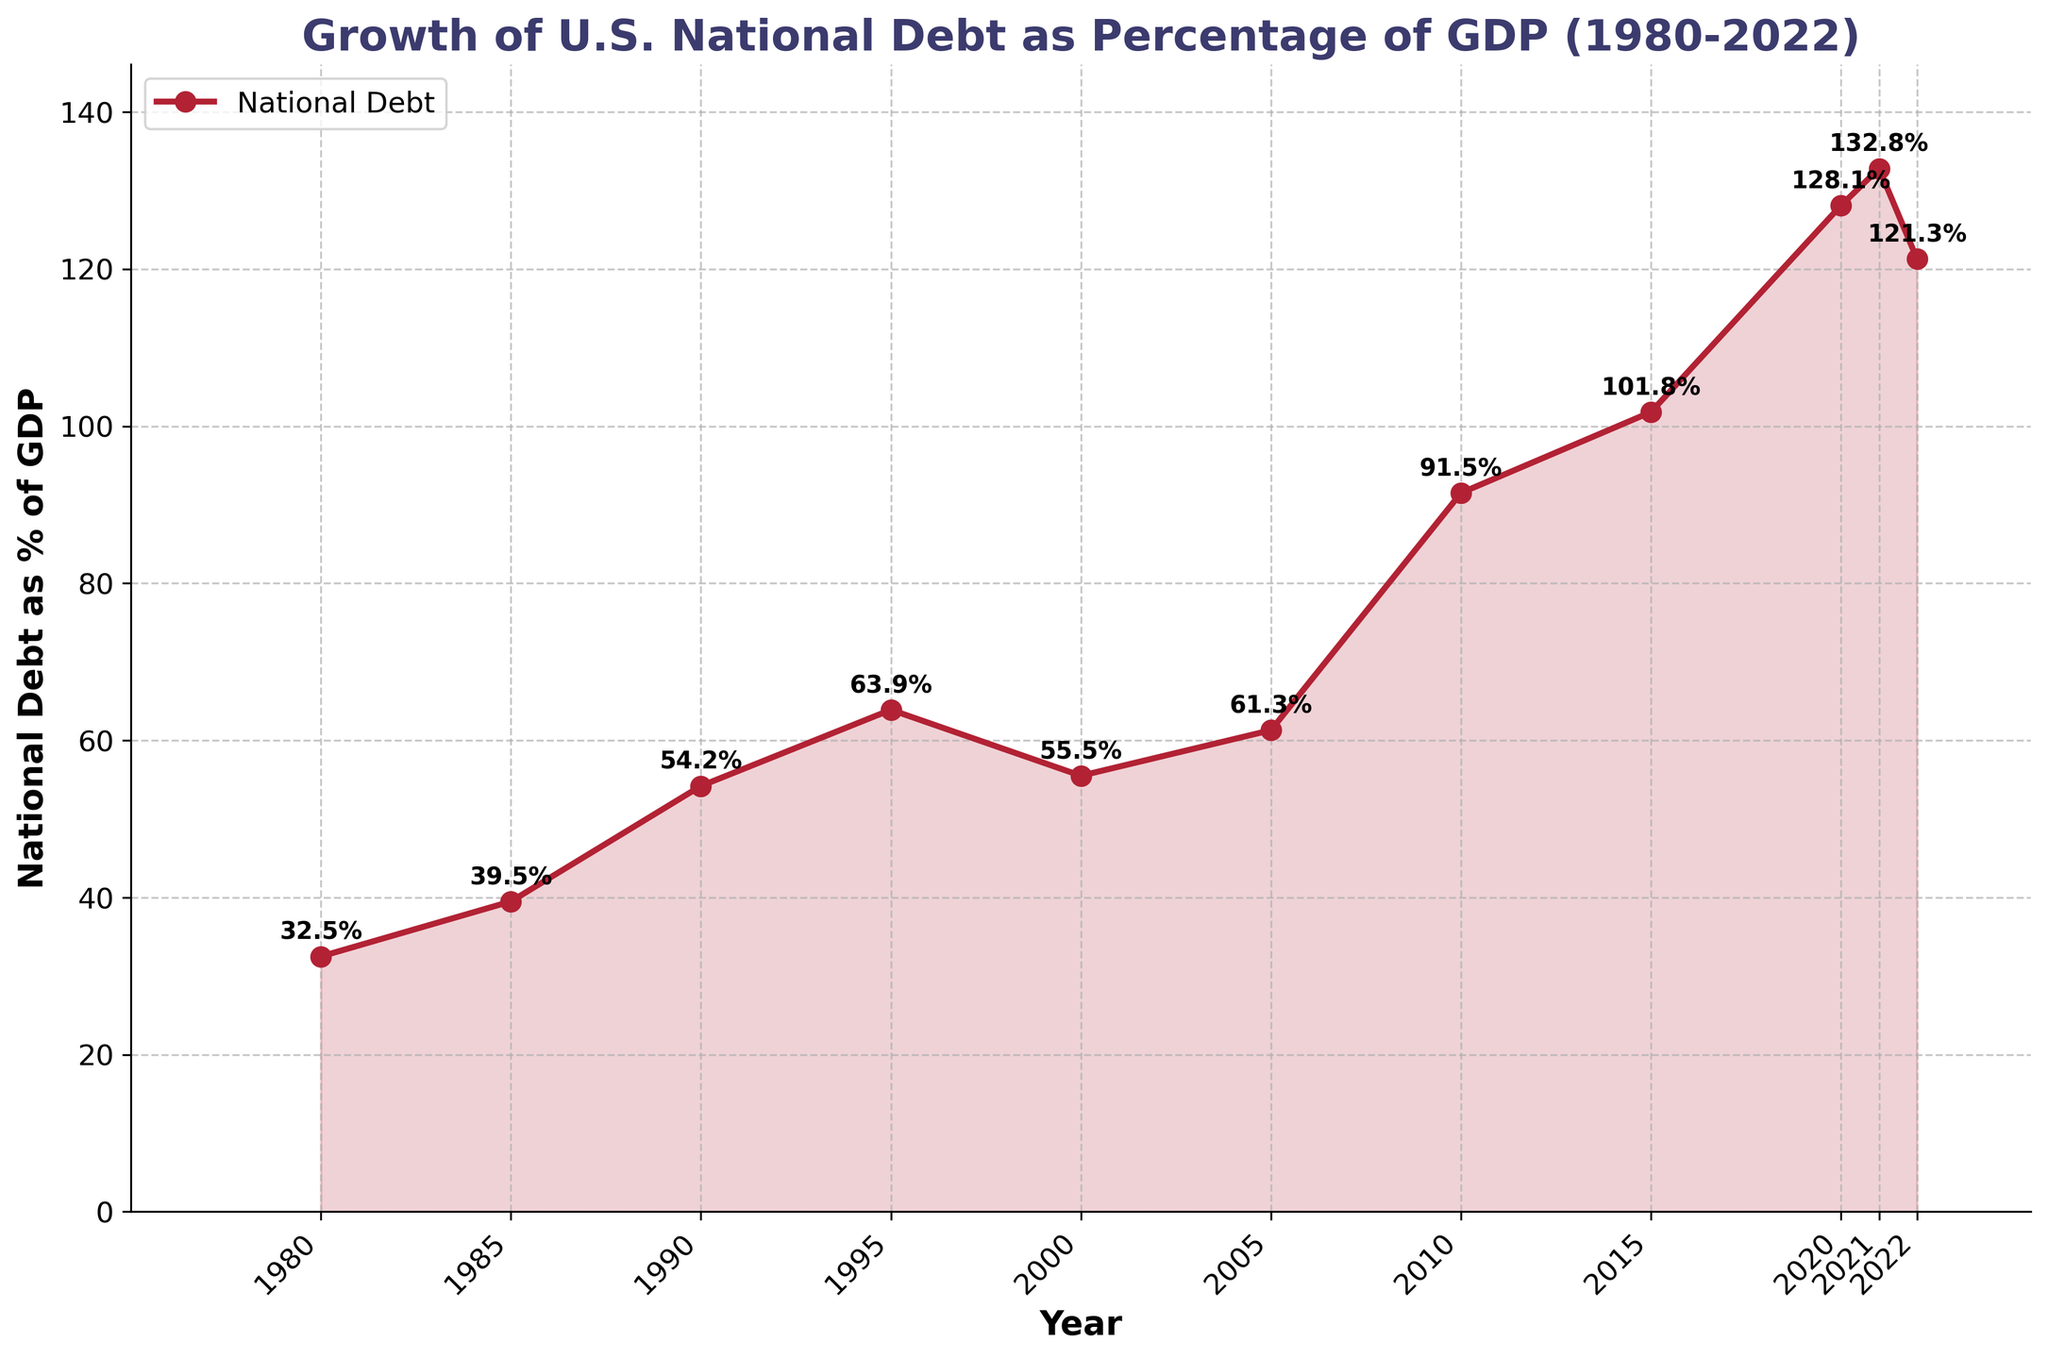How much did the national debt as a percentage of GDP increase from 1980 to 2022? To find the increase, subtract the percentage in 1980 (32.5%) from the percentage in 2022 (121.3%). 121.3% - 32.5% = 88.8%.
Answer: 88.8% In which year did the national debt as a percentage of GDP first exceed 100%? Find the earliest year on the x-axis where the percentage crosses 100%. This occurs in 2015 with 101.8%.
Answer: 2015 What’s the difference in national debt as a percentage of GDP between 2000 and 2010? Subtract the percentage in 2000 (55.5%) from the percentage in 2010 (91.5%). 91.5% - 55.5% = 36%.
Answer: 36% Did the national debt as a percentage of GDP ever decrease between consecutive years? If so, provide an example. Identify any year where the line chart shows a decline in subsequent years. From 2021 (132.8%) to 2022 (121.3%), there is a decrease.
Answer: Yes, from 2021 to 2022 In which decade did the national debt as a percentage of GDP grow the most? Calculate the difference in percentages at the start and end of each decade. The largest growth is between 2000 (55.5%) and 2010 (91.5%), which is 36%.
Answer: 2000s Which year saw the largest single-year increase in national debt as a percentage of GDP? Look for the steepest incline in the line chart. The largest single-year increase is between 2019 and 2020, from 101.8% to 128.1%, which is 26.3%.
Answer: 2019 to 2020 What is the average national debt as a percentage of GDP from 1980 to 2022? Add up all the percentages provided and divide by the number of years (11). Sum: 790.4, Average: 790.4 / 11 = 71.855.
Answer: 71.9% How many times did the national debt as a percentage of GDP increase compared to the previous year? Count the number of periods where the percentage increased. Apart from 2022, it increased in each successive year up till 2021. Therefore, it increased 10 times.
Answer: 10 times 